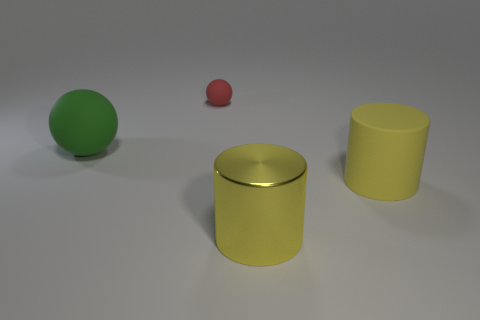Is there anything else that is the same size as the red thing?
Provide a short and direct response. No. What number of yellow objects are either large metallic cylinders or rubber objects?
Keep it short and to the point. 2. There is a large yellow cylinder that is on the left side of the rubber thing to the right of the small matte thing; are there any rubber objects to the left of it?
Offer a terse response. Yes. Is the number of big yellow things less than the number of big cubes?
Your response must be concise. No. Does the large thing that is to the left of the small red ball have the same shape as the small red object?
Make the answer very short. Yes. Are any big green rubber spheres visible?
Offer a terse response. Yes. There is a matte object right of the large object in front of the large matte thing in front of the big green rubber object; what color is it?
Offer a terse response. Yellow. Are there the same number of metal cylinders behind the big metallic cylinder and yellow matte cylinders that are behind the yellow matte cylinder?
Offer a very short reply. Yes. What shape is the yellow thing that is the same size as the metal cylinder?
Give a very brief answer. Cylinder. Is there another thing of the same color as the small object?
Give a very brief answer. No. 